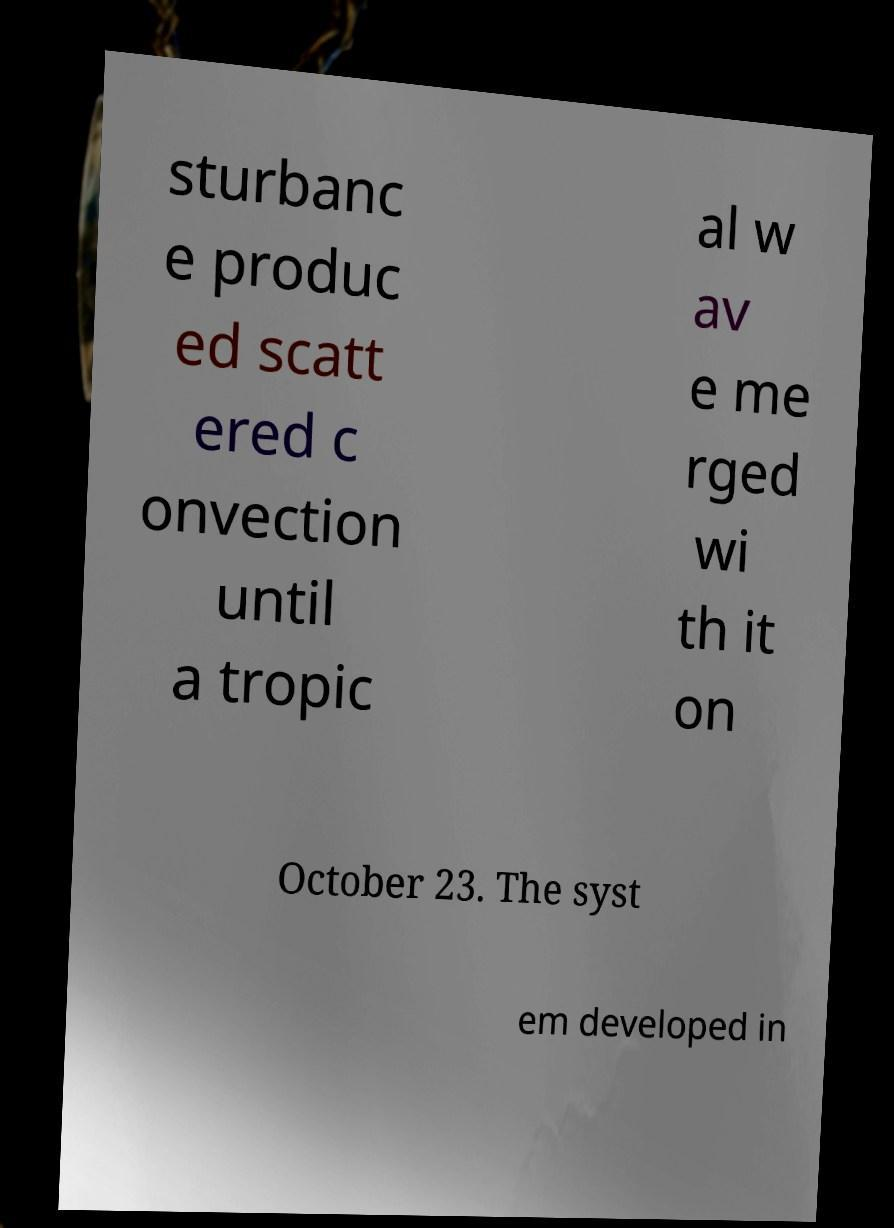Can you read and provide the text displayed in the image?This photo seems to have some interesting text. Can you extract and type it out for me? sturbanc e produc ed scatt ered c onvection until a tropic al w av e me rged wi th it on October 23. The syst em developed in 